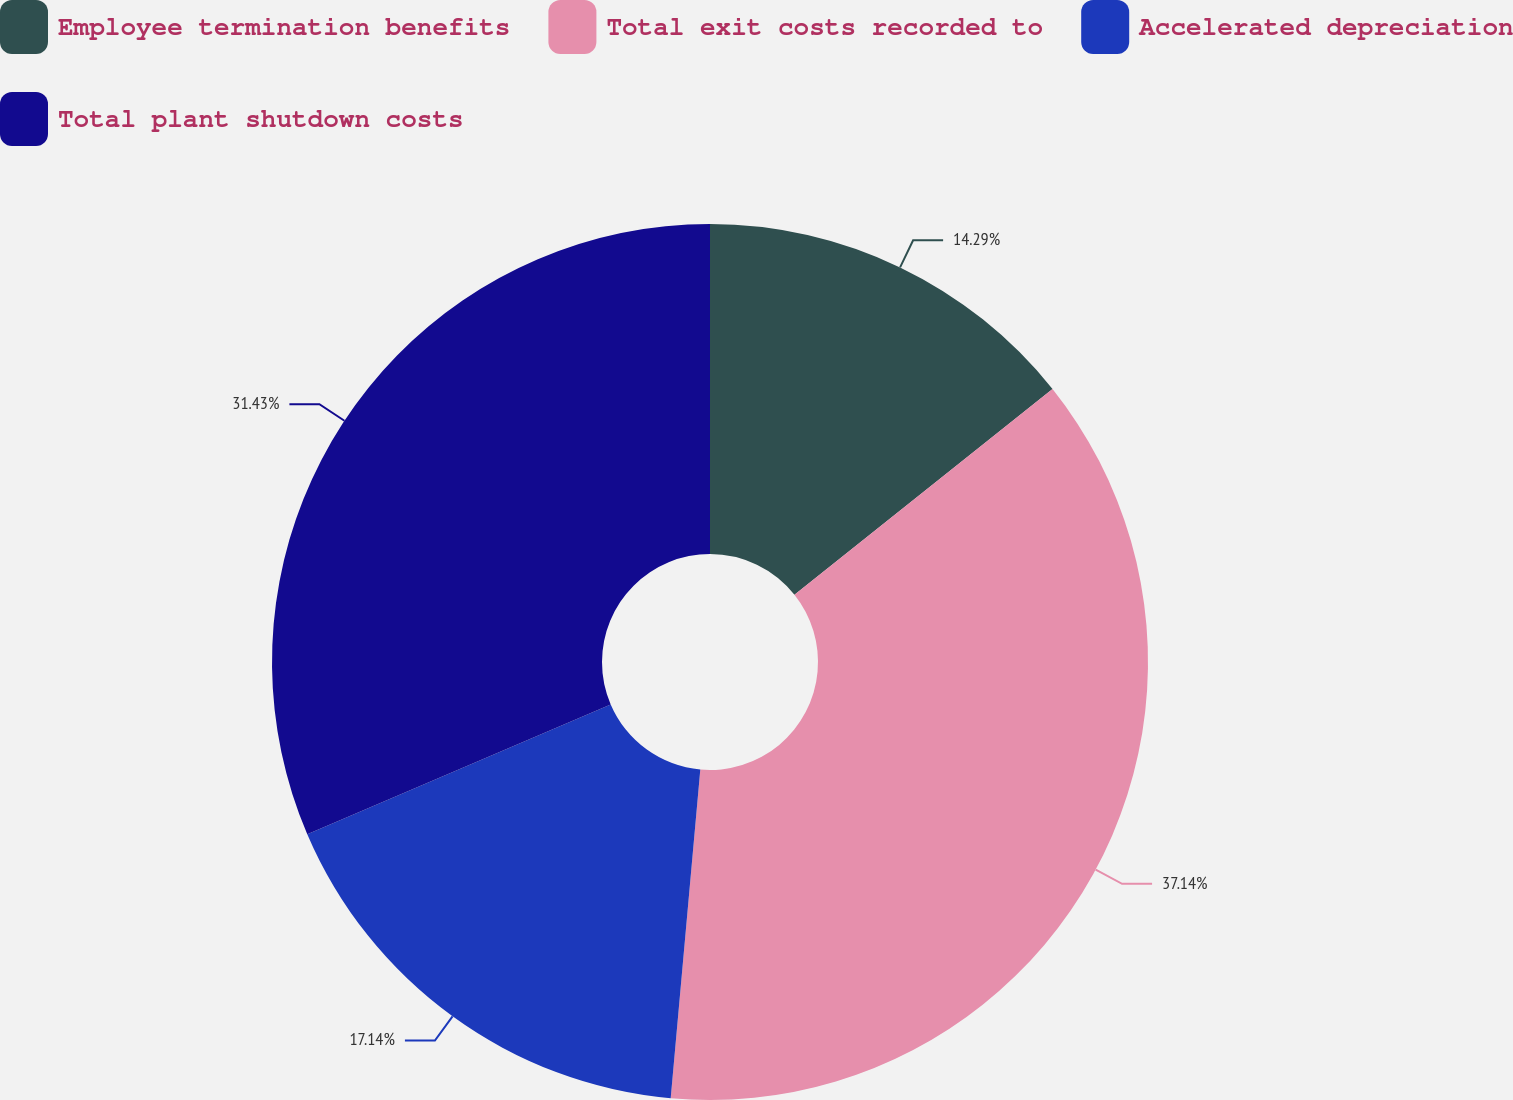Convert chart to OTSL. <chart><loc_0><loc_0><loc_500><loc_500><pie_chart><fcel>Employee termination benefits<fcel>Total exit costs recorded to<fcel>Accelerated depreciation<fcel>Total plant shutdown costs<nl><fcel>14.29%<fcel>37.14%<fcel>17.14%<fcel>31.43%<nl></chart> 